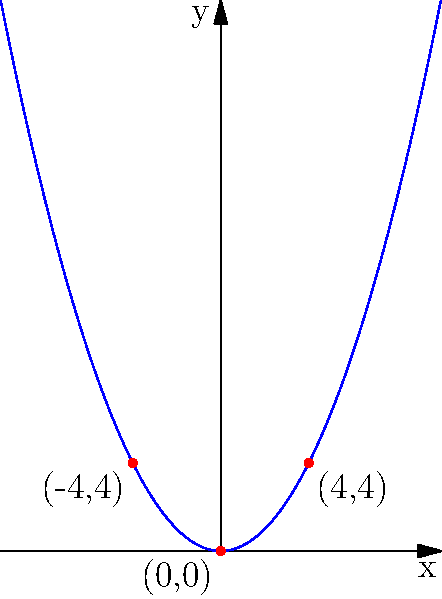As part of a drone light show for a festival, you need to program a group of drones to follow a parabolic path to create a symmetrical arch effect. The path is defined by the equation $y = ax^2$, where $a > 0$. Given that the path passes through the points $(-4, 4)$ and $(4, 4)$, determine the value of $a$ and write the equation of the parabola. Let's approach this step-by-step:

1) We know the general form of the parabola is $y = ax^2$, where $a > 0$ (because the parabola opens upward).

2) We're given two points on the parabola: $(-4, 4)$ and $(4, 4)$. Let's use one of these points to find $a$.

3) Using the point $(4, 4)$:
   $4 = a(4)^2$
   $4 = 16a$

4) Solving for $a$:
   $a = 4/16 = 1/4 = 0.25$

5) We can verify this using the point $(-4, 4)$:
   $4 = a(-4)^2 = 0.25(16) = 4$, which checks out.

6) Now that we have $a$, we can write the full equation of the parabola:
   $y = 0.25x^2$

This equation describes the path that the drones should follow to create the symmetrical arch effect in the night sky.
Answer: $y = 0.25x^2$ 